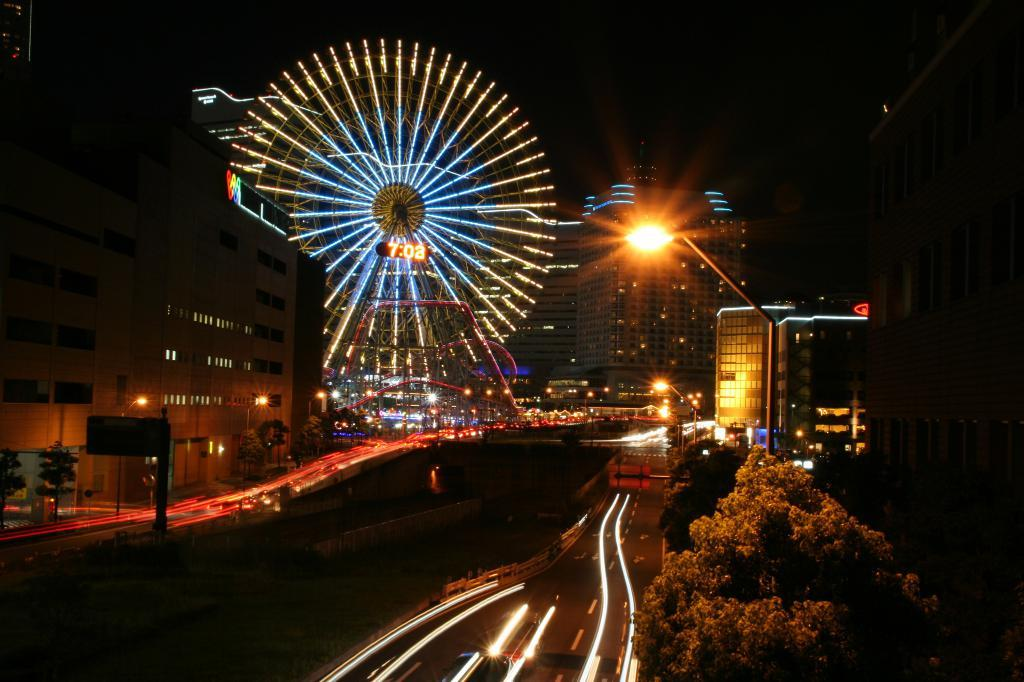What is the main attraction in the image? There is a giant-wheel in the image. What time-related object can be seen in the image? There is a digital clock in the image. What structures are present to provide illumination in the image? There are light poles in the image. What surface is available for displaying information or advertisements? There is a board in the image. What type of natural vegetation is present in the image? There are trees in the image. What type of man-made structures are visible in the image? There are buildings in the image. What type of pollution is visible in the image? There is no visible pollution in the image. What religious belief is being practiced in the image? There is no indication of any religious belief being practiced in the image. 